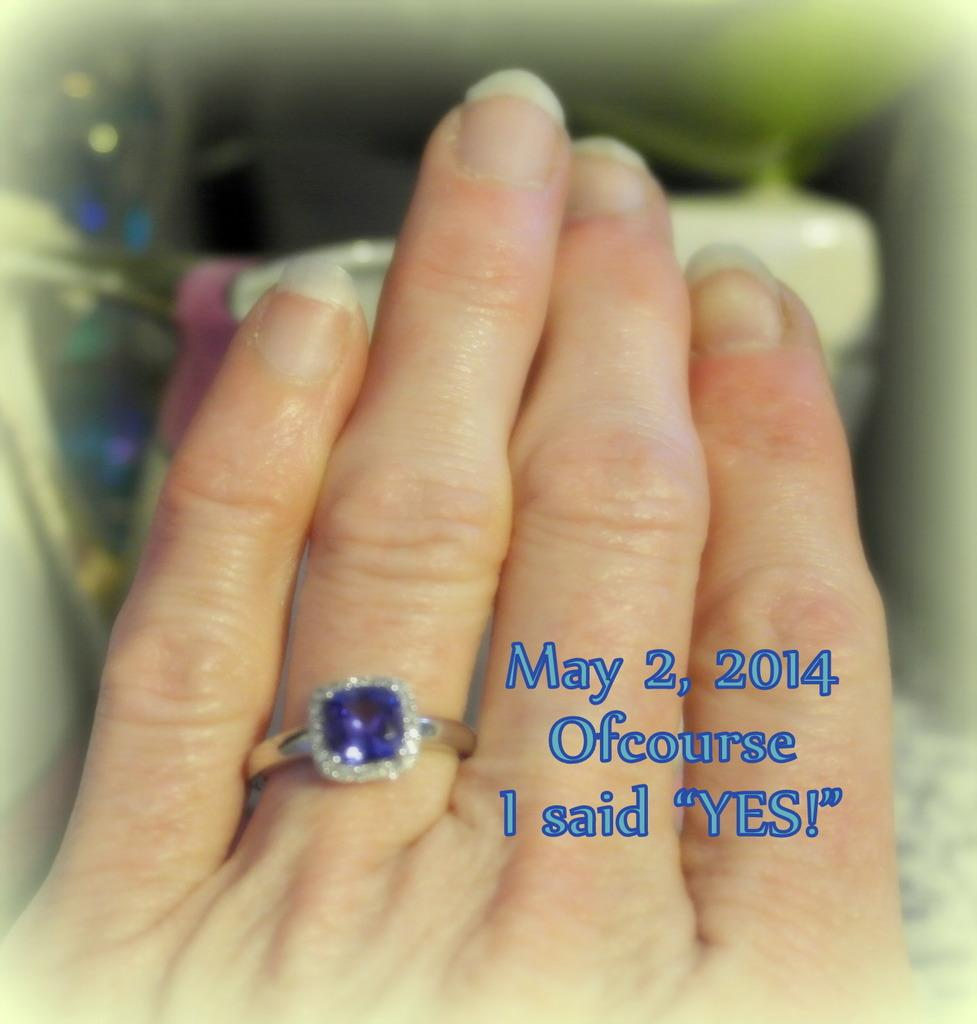What part of a person can be seen in the image? There is a hand of a person in the image. What type of accessory is present on the hand? There is a ring in the image. What else is featured in the image besides the hand and the ring? There is some text visible in the image. What color is the zephyr in the image? There is no zephyr present in the image. Can you tell me how many airplanes are visible in the image? There are no airplanes visible in the image. 